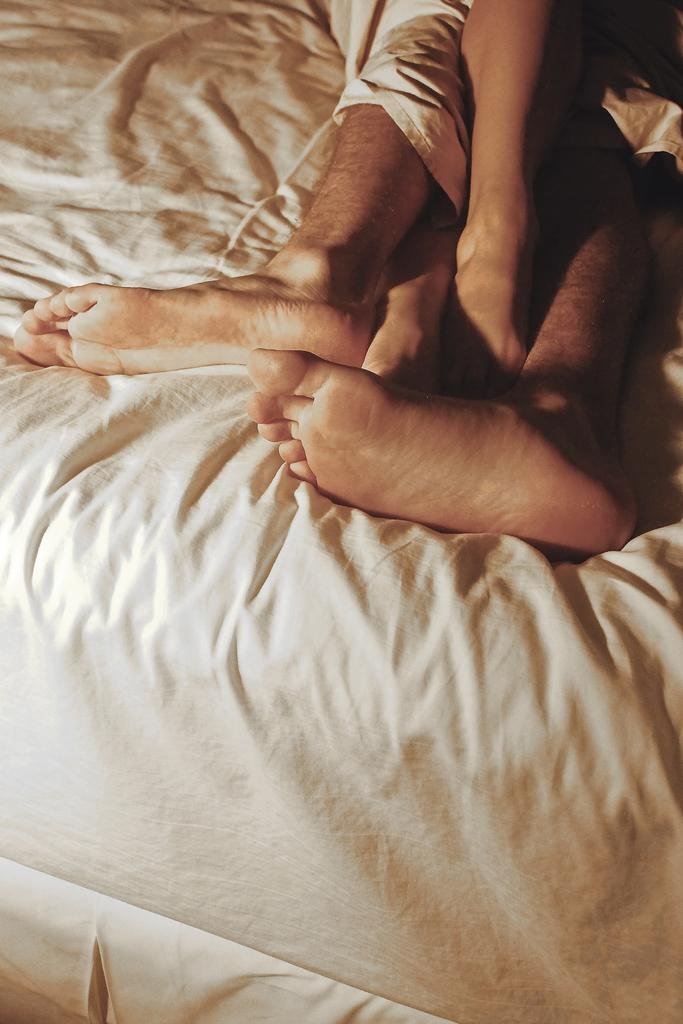How many sets of legs can be seen in the image? There are legs of two persons visible in the image. Where are the legs located? The legs are lying on a bed. What type of table is being used for the example in the image? There is no table present in the image, and no example is being demonstrated. 